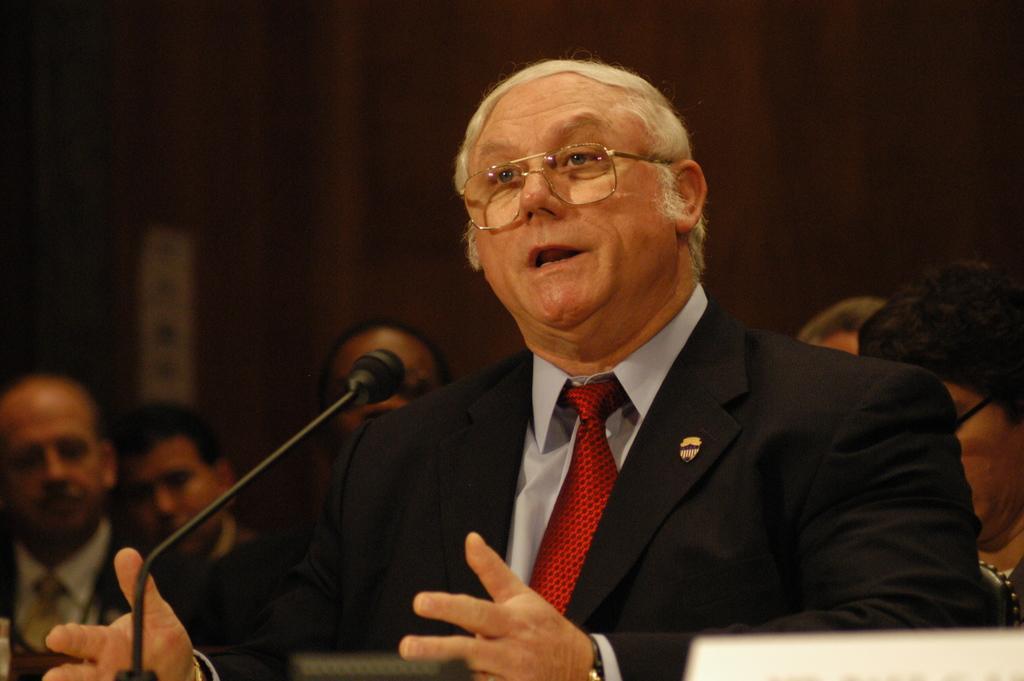In one or two sentences, can you explain what this image depicts? In this image we can see a man wearing the suit and talking in front of the mike. We can also see some persons in the background and the background is not clear. 